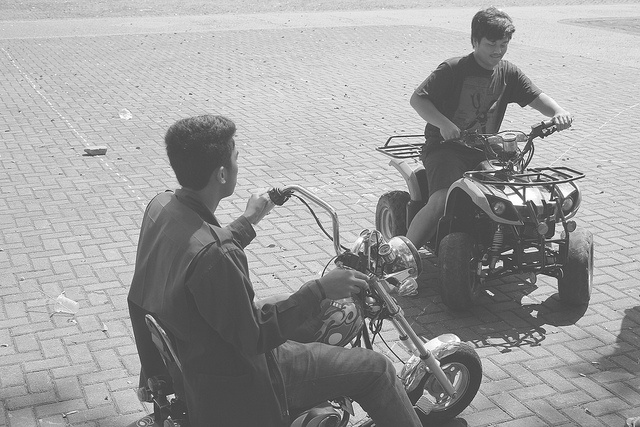Describe the objects in this image and their specific colors. I can see people in lightgray, gray, and black tones, motorcycle in lightgray, gray, darkgray, and black tones, people in lightgray, gray, darkgray, and black tones, and motorcycle in lightgray, gray, darkgray, gainsboro, and black tones in this image. 